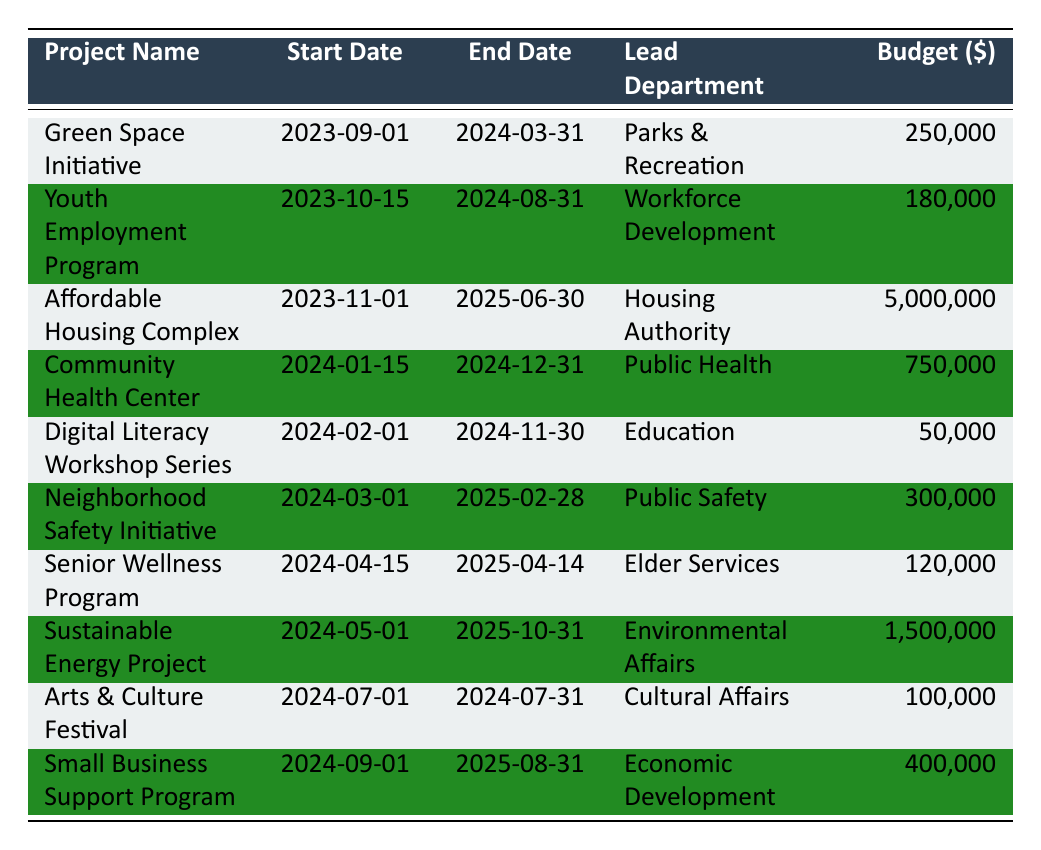What is the budget for the Affordable Housing Complex? The table shows the budget for the Affordable Housing Complex as $5,000,000 under the "Budget ($)" column.
Answer: 5,000,000 When does the Digital Literacy Workshop Series start? Referring to the "Start Date" column, the Digital Literacy Workshop Series begins on 2024-02-01.
Answer: 2024-02-01 How many projects are led by the Parks & Recreation department? Only one project, the Green Space Initiative, is led by the Parks & Recreation department, as confirmed by the "Lead Department" column.
Answer: 1 What is the total budget for projects starting in 2024? The projects starting in 2024 are the Community Health Center ($750,000), Digital Literacy Workshop Series ($50,000), Neighborhood Safety Initiative ($300,000), Senior Wellness Program ($120,000), Sustainable Energy Project ($1,500,000), Arts & Culture Festival ($100,000), and Small Business Support Program ($400,000). Total budget is $750,000 + $50,000 + $300,000 + $120,000 + $1,500,000 + $100,000 + $400,000 = $3,220,000.
Answer: 3,220,000 Is the Youth Employment Program budget greater than the Senior Wellness Program budget? The budget for the Youth Employment Program is $180,000, while the budget for the Senior Wellness Program is $120,000. Since 180,000 is greater than 120,000, the statement is true.
Answer: Yes Which project has the longest duration from start to end date? To find the longest duration, we look at each project’s end date minus its start date. The Affordable Housing Complex spans from 2023-11-01 to 2025-06-30, which is 20 months, making it the project with the longest duration compared to the others.
Answer: Affordable Housing Complex 